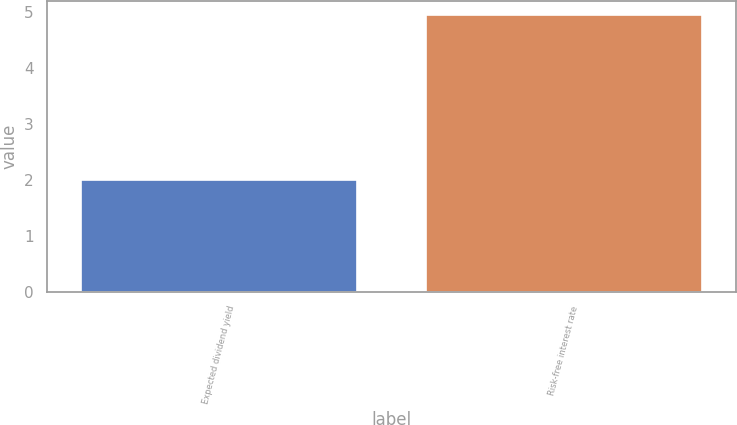Convert chart. <chart><loc_0><loc_0><loc_500><loc_500><bar_chart><fcel>Expected dividend yield<fcel>Risk-free interest rate<nl><fcel>2<fcel>4.95<nl></chart> 